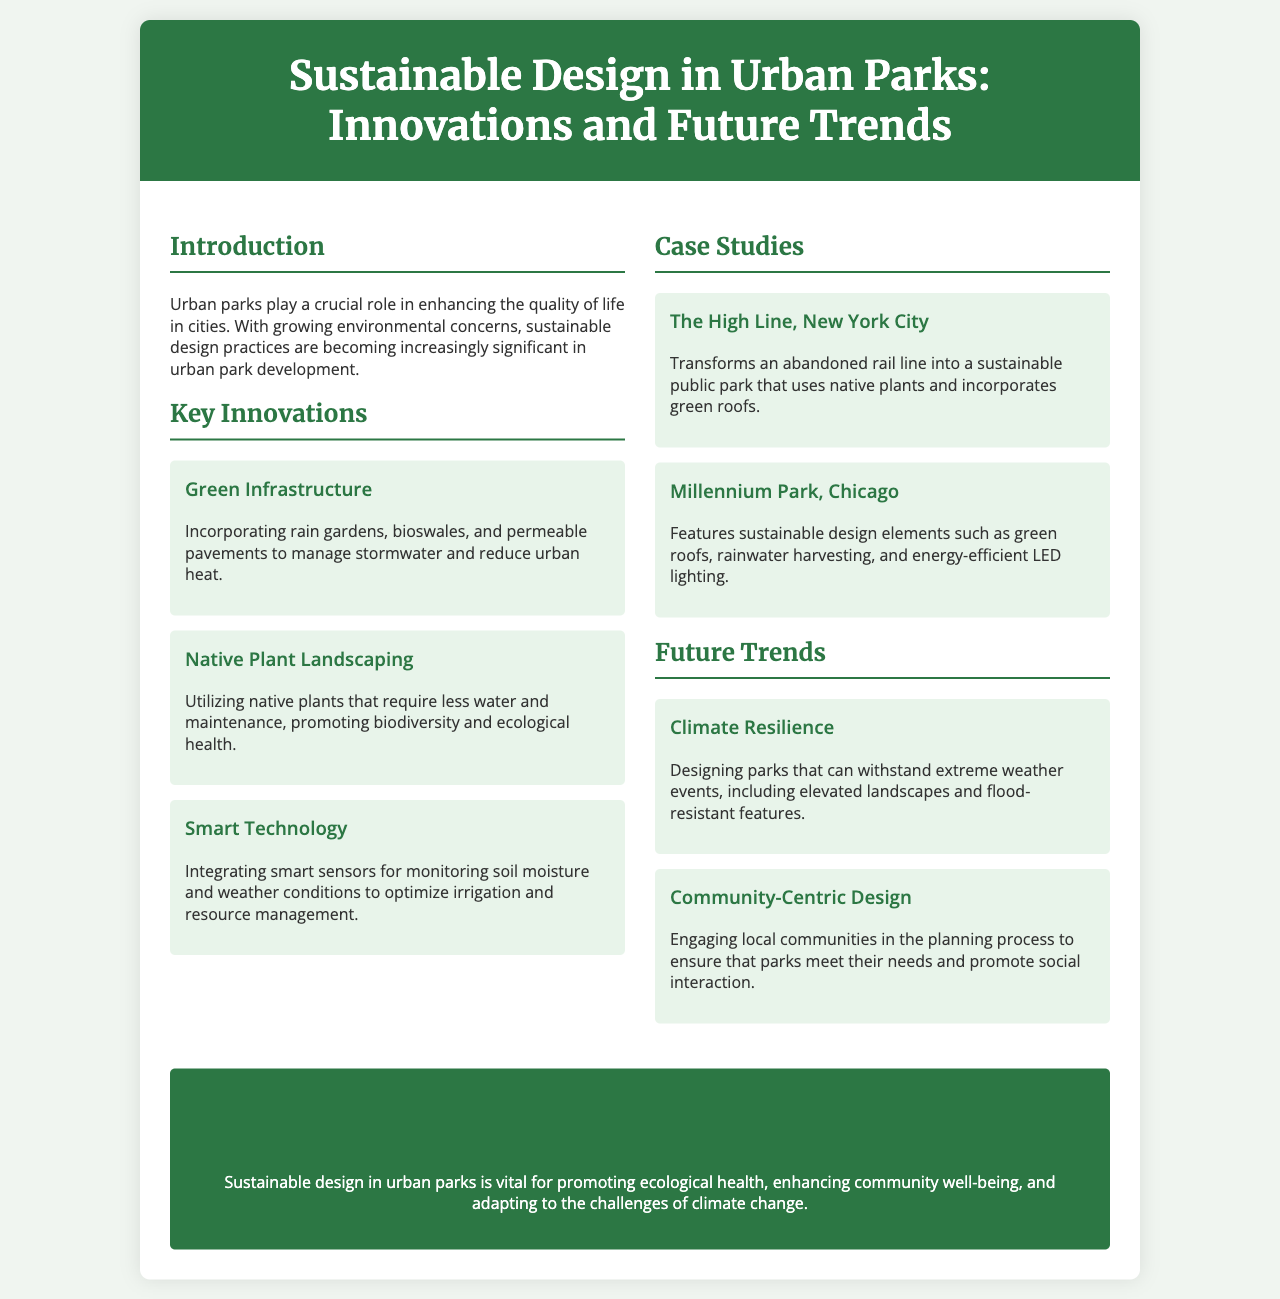What is the title of the brochure? The title is prominently displayed at the top of the document.
Answer: Sustainable Design in Urban Parks: Innovations and Future Trends What is one of the key innovations mentioned in the document? The brochure lists several innovations in a specific section dedicated to them.
Answer: Green Infrastructure Which urban park is mentioned as a case study in New York City? The document provides specific examples of urban parks under the case studies section.
Answer: The High Line What future trend focuses on community involvement? This is addressed in the section discussing future trends, highlighting a specific aspect of park design.
Answer: Community-Centric Design How many case studies are presented in the document? The document explicitly lists the case studies, making it easy to count them.
Answer: 2 What is one benefit of using native plants in urban parks? The brochure outlines advantages related to plant selection in the key innovations section.
Answer: Promoting biodiversity What is the color used for the header background? The color of the header is specified in the document's style settings and is visually prominent.
Answer: Dark green What is emphasized in the conclusion of the brochure? The final section summarizes the main ideas and significance of sustainable design.
Answer: Ecological health 